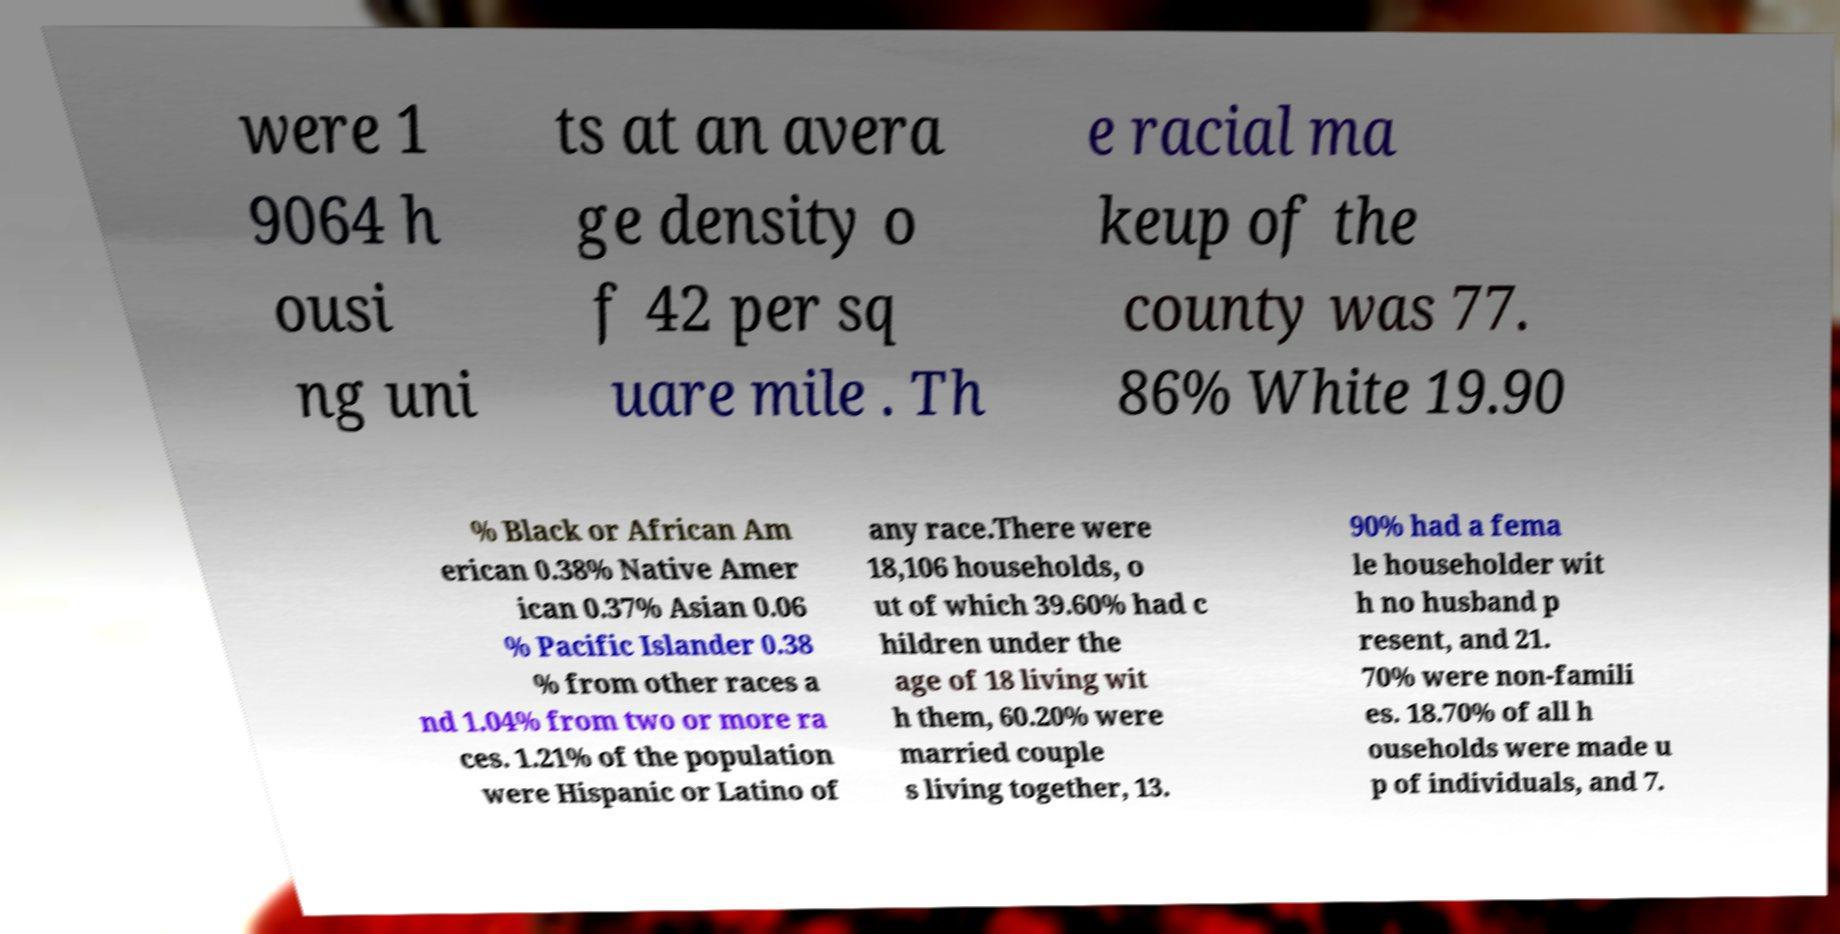There's text embedded in this image that I need extracted. Can you transcribe it verbatim? were 1 9064 h ousi ng uni ts at an avera ge density o f 42 per sq uare mile . Th e racial ma keup of the county was 77. 86% White 19.90 % Black or African Am erican 0.38% Native Amer ican 0.37% Asian 0.06 % Pacific Islander 0.38 % from other races a nd 1.04% from two or more ra ces. 1.21% of the population were Hispanic or Latino of any race.There were 18,106 households, o ut of which 39.60% had c hildren under the age of 18 living wit h them, 60.20% were married couple s living together, 13. 90% had a fema le householder wit h no husband p resent, and 21. 70% were non-famili es. 18.70% of all h ouseholds were made u p of individuals, and 7. 